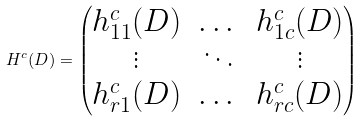Convert formula to latex. <formula><loc_0><loc_0><loc_500><loc_500>H ^ { c } ( D ) = \begin{pmatrix} h _ { 1 1 } ^ { c } ( D ) & \dots & h _ { 1 c } ^ { c } ( D ) \\ \vdots & \ddots & \vdots \\ h _ { r 1 } ^ { c } ( D ) & \dots & h _ { r c } ^ { c } ( D ) \end{pmatrix}</formula> 